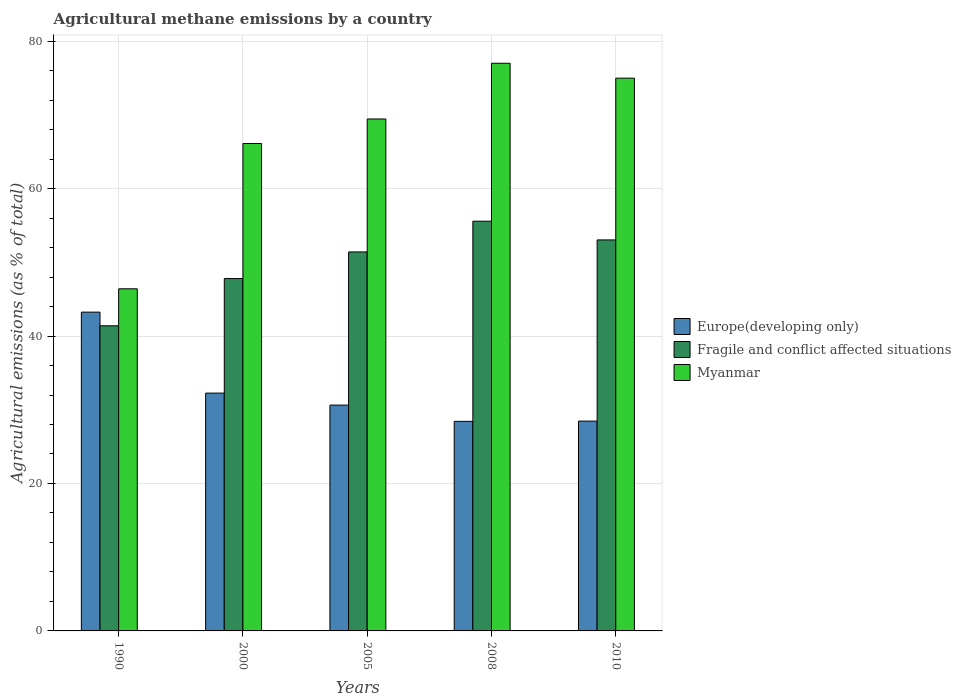How many groups of bars are there?
Keep it short and to the point. 5. Are the number of bars on each tick of the X-axis equal?
Your response must be concise. Yes. What is the amount of agricultural methane emitted in Fragile and conflict affected situations in 1990?
Your answer should be very brief. 41.39. Across all years, what is the maximum amount of agricultural methane emitted in Europe(developing only)?
Give a very brief answer. 43.24. Across all years, what is the minimum amount of agricultural methane emitted in Fragile and conflict affected situations?
Your answer should be compact. 41.39. In which year was the amount of agricultural methane emitted in Europe(developing only) minimum?
Provide a succinct answer. 2008. What is the total amount of agricultural methane emitted in Myanmar in the graph?
Offer a terse response. 333.95. What is the difference between the amount of agricultural methane emitted in Myanmar in 1990 and that in 2008?
Your response must be concise. -30.59. What is the difference between the amount of agricultural methane emitted in Europe(developing only) in 2000 and the amount of agricultural methane emitted in Fragile and conflict affected situations in 2005?
Offer a terse response. -19.15. What is the average amount of agricultural methane emitted in Fragile and conflict affected situations per year?
Offer a very short reply. 49.84. In the year 2008, what is the difference between the amount of agricultural methane emitted in Myanmar and amount of agricultural methane emitted in Europe(developing only)?
Provide a short and direct response. 48.57. In how many years, is the amount of agricultural methane emitted in Fragile and conflict affected situations greater than 52 %?
Offer a very short reply. 2. What is the ratio of the amount of agricultural methane emitted in Myanmar in 1990 to that in 2005?
Give a very brief answer. 0.67. Is the amount of agricultural methane emitted in Myanmar in 1990 less than that in 2008?
Provide a succinct answer. Yes. What is the difference between the highest and the second highest amount of agricultural methane emitted in Myanmar?
Your answer should be compact. 2.02. What is the difference between the highest and the lowest amount of agricultural methane emitted in Fragile and conflict affected situations?
Offer a very short reply. 14.19. Is the sum of the amount of agricultural methane emitted in Europe(developing only) in 1990 and 2010 greater than the maximum amount of agricultural methane emitted in Myanmar across all years?
Your answer should be very brief. No. What does the 1st bar from the left in 2005 represents?
Provide a succinct answer. Europe(developing only). What does the 3rd bar from the right in 2008 represents?
Offer a terse response. Europe(developing only). Is it the case that in every year, the sum of the amount of agricultural methane emitted in Europe(developing only) and amount of agricultural methane emitted in Myanmar is greater than the amount of agricultural methane emitted in Fragile and conflict affected situations?
Offer a terse response. Yes. How many bars are there?
Give a very brief answer. 15. Are all the bars in the graph horizontal?
Make the answer very short. No. How many years are there in the graph?
Make the answer very short. 5. Are the values on the major ticks of Y-axis written in scientific E-notation?
Offer a terse response. No. Does the graph contain grids?
Give a very brief answer. Yes. What is the title of the graph?
Provide a succinct answer. Agricultural methane emissions by a country. Does "Monaco" appear as one of the legend labels in the graph?
Your response must be concise. No. What is the label or title of the X-axis?
Offer a terse response. Years. What is the label or title of the Y-axis?
Make the answer very short. Agricultural emissions (as % of total). What is the Agricultural emissions (as % of total) of Europe(developing only) in 1990?
Your answer should be compact. 43.24. What is the Agricultural emissions (as % of total) of Fragile and conflict affected situations in 1990?
Give a very brief answer. 41.39. What is the Agricultural emissions (as % of total) of Myanmar in 1990?
Provide a short and direct response. 46.41. What is the Agricultural emissions (as % of total) of Europe(developing only) in 2000?
Offer a very short reply. 32.26. What is the Agricultural emissions (as % of total) of Fragile and conflict affected situations in 2000?
Provide a succinct answer. 47.8. What is the Agricultural emissions (as % of total) in Myanmar in 2000?
Keep it short and to the point. 66.12. What is the Agricultural emissions (as % of total) in Europe(developing only) in 2005?
Provide a succinct answer. 30.63. What is the Agricultural emissions (as % of total) of Fragile and conflict affected situations in 2005?
Provide a short and direct response. 51.41. What is the Agricultural emissions (as % of total) of Myanmar in 2005?
Ensure brevity in your answer.  69.44. What is the Agricultural emissions (as % of total) in Europe(developing only) in 2008?
Offer a terse response. 28.43. What is the Agricultural emissions (as % of total) in Fragile and conflict affected situations in 2008?
Offer a terse response. 55.58. What is the Agricultural emissions (as % of total) of Myanmar in 2008?
Give a very brief answer. 77. What is the Agricultural emissions (as % of total) of Europe(developing only) in 2010?
Make the answer very short. 28.46. What is the Agricultural emissions (as % of total) of Fragile and conflict affected situations in 2010?
Ensure brevity in your answer.  53.04. What is the Agricultural emissions (as % of total) in Myanmar in 2010?
Make the answer very short. 74.98. Across all years, what is the maximum Agricultural emissions (as % of total) in Europe(developing only)?
Your response must be concise. 43.24. Across all years, what is the maximum Agricultural emissions (as % of total) of Fragile and conflict affected situations?
Give a very brief answer. 55.58. Across all years, what is the maximum Agricultural emissions (as % of total) of Myanmar?
Offer a very short reply. 77. Across all years, what is the minimum Agricultural emissions (as % of total) in Europe(developing only)?
Your answer should be compact. 28.43. Across all years, what is the minimum Agricultural emissions (as % of total) of Fragile and conflict affected situations?
Provide a succinct answer. 41.39. Across all years, what is the minimum Agricultural emissions (as % of total) of Myanmar?
Keep it short and to the point. 46.41. What is the total Agricultural emissions (as % of total) in Europe(developing only) in the graph?
Your answer should be very brief. 163.02. What is the total Agricultural emissions (as % of total) of Fragile and conflict affected situations in the graph?
Offer a very short reply. 249.21. What is the total Agricultural emissions (as % of total) of Myanmar in the graph?
Keep it short and to the point. 333.95. What is the difference between the Agricultural emissions (as % of total) in Europe(developing only) in 1990 and that in 2000?
Offer a terse response. 10.98. What is the difference between the Agricultural emissions (as % of total) of Fragile and conflict affected situations in 1990 and that in 2000?
Make the answer very short. -6.41. What is the difference between the Agricultural emissions (as % of total) of Myanmar in 1990 and that in 2000?
Provide a succinct answer. -19.71. What is the difference between the Agricultural emissions (as % of total) in Europe(developing only) in 1990 and that in 2005?
Offer a terse response. 12.61. What is the difference between the Agricultural emissions (as % of total) in Fragile and conflict affected situations in 1990 and that in 2005?
Your response must be concise. -10.02. What is the difference between the Agricultural emissions (as % of total) in Myanmar in 1990 and that in 2005?
Make the answer very short. -23.03. What is the difference between the Agricultural emissions (as % of total) of Europe(developing only) in 1990 and that in 2008?
Offer a very short reply. 14.82. What is the difference between the Agricultural emissions (as % of total) of Fragile and conflict affected situations in 1990 and that in 2008?
Give a very brief answer. -14.19. What is the difference between the Agricultural emissions (as % of total) in Myanmar in 1990 and that in 2008?
Offer a terse response. -30.59. What is the difference between the Agricultural emissions (as % of total) in Europe(developing only) in 1990 and that in 2010?
Give a very brief answer. 14.78. What is the difference between the Agricultural emissions (as % of total) in Fragile and conflict affected situations in 1990 and that in 2010?
Keep it short and to the point. -11.65. What is the difference between the Agricultural emissions (as % of total) of Myanmar in 1990 and that in 2010?
Your answer should be compact. -28.57. What is the difference between the Agricultural emissions (as % of total) in Europe(developing only) in 2000 and that in 2005?
Your answer should be compact. 1.63. What is the difference between the Agricultural emissions (as % of total) in Fragile and conflict affected situations in 2000 and that in 2005?
Provide a short and direct response. -3.61. What is the difference between the Agricultural emissions (as % of total) in Myanmar in 2000 and that in 2005?
Provide a succinct answer. -3.32. What is the difference between the Agricultural emissions (as % of total) in Europe(developing only) in 2000 and that in 2008?
Make the answer very short. 3.83. What is the difference between the Agricultural emissions (as % of total) in Fragile and conflict affected situations in 2000 and that in 2008?
Offer a terse response. -7.78. What is the difference between the Agricultural emissions (as % of total) of Myanmar in 2000 and that in 2008?
Your response must be concise. -10.88. What is the difference between the Agricultural emissions (as % of total) of Europe(developing only) in 2000 and that in 2010?
Provide a succinct answer. 3.8. What is the difference between the Agricultural emissions (as % of total) of Fragile and conflict affected situations in 2000 and that in 2010?
Give a very brief answer. -5.24. What is the difference between the Agricultural emissions (as % of total) in Myanmar in 2000 and that in 2010?
Provide a succinct answer. -8.86. What is the difference between the Agricultural emissions (as % of total) in Europe(developing only) in 2005 and that in 2008?
Your response must be concise. 2.2. What is the difference between the Agricultural emissions (as % of total) in Fragile and conflict affected situations in 2005 and that in 2008?
Offer a very short reply. -4.17. What is the difference between the Agricultural emissions (as % of total) of Myanmar in 2005 and that in 2008?
Keep it short and to the point. -7.56. What is the difference between the Agricultural emissions (as % of total) of Europe(developing only) in 2005 and that in 2010?
Your response must be concise. 2.17. What is the difference between the Agricultural emissions (as % of total) of Fragile and conflict affected situations in 2005 and that in 2010?
Offer a terse response. -1.63. What is the difference between the Agricultural emissions (as % of total) in Myanmar in 2005 and that in 2010?
Give a very brief answer. -5.54. What is the difference between the Agricultural emissions (as % of total) of Europe(developing only) in 2008 and that in 2010?
Offer a terse response. -0.03. What is the difference between the Agricultural emissions (as % of total) in Fragile and conflict affected situations in 2008 and that in 2010?
Provide a succinct answer. 2.54. What is the difference between the Agricultural emissions (as % of total) in Myanmar in 2008 and that in 2010?
Keep it short and to the point. 2.02. What is the difference between the Agricultural emissions (as % of total) in Europe(developing only) in 1990 and the Agricultural emissions (as % of total) in Fragile and conflict affected situations in 2000?
Give a very brief answer. -4.55. What is the difference between the Agricultural emissions (as % of total) of Europe(developing only) in 1990 and the Agricultural emissions (as % of total) of Myanmar in 2000?
Give a very brief answer. -22.88. What is the difference between the Agricultural emissions (as % of total) in Fragile and conflict affected situations in 1990 and the Agricultural emissions (as % of total) in Myanmar in 2000?
Your answer should be very brief. -24.73. What is the difference between the Agricultural emissions (as % of total) of Europe(developing only) in 1990 and the Agricultural emissions (as % of total) of Fragile and conflict affected situations in 2005?
Your answer should be compact. -8.17. What is the difference between the Agricultural emissions (as % of total) of Europe(developing only) in 1990 and the Agricultural emissions (as % of total) of Myanmar in 2005?
Ensure brevity in your answer.  -26.2. What is the difference between the Agricultural emissions (as % of total) in Fragile and conflict affected situations in 1990 and the Agricultural emissions (as % of total) in Myanmar in 2005?
Your answer should be very brief. -28.05. What is the difference between the Agricultural emissions (as % of total) in Europe(developing only) in 1990 and the Agricultural emissions (as % of total) in Fragile and conflict affected situations in 2008?
Your answer should be very brief. -12.34. What is the difference between the Agricultural emissions (as % of total) of Europe(developing only) in 1990 and the Agricultural emissions (as % of total) of Myanmar in 2008?
Ensure brevity in your answer.  -33.76. What is the difference between the Agricultural emissions (as % of total) of Fragile and conflict affected situations in 1990 and the Agricultural emissions (as % of total) of Myanmar in 2008?
Your answer should be compact. -35.61. What is the difference between the Agricultural emissions (as % of total) of Europe(developing only) in 1990 and the Agricultural emissions (as % of total) of Fragile and conflict affected situations in 2010?
Your response must be concise. -9.8. What is the difference between the Agricultural emissions (as % of total) in Europe(developing only) in 1990 and the Agricultural emissions (as % of total) in Myanmar in 2010?
Offer a very short reply. -31.74. What is the difference between the Agricultural emissions (as % of total) of Fragile and conflict affected situations in 1990 and the Agricultural emissions (as % of total) of Myanmar in 2010?
Your response must be concise. -33.59. What is the difference between the Agricultural emissions (as % of total) in Europe(developing only) in 2000 and the Agricultural emissions (as % of total) in Fragile and conflict affected situations in 2005?
Your response must be concise. -19.15. What is the difference between the Agricultural emissions (as % of total) in Europe(developing only) in 2000 and the Agricultural emissions (as % of total) in Myanmar in 2005?
Ensure brevity in your answer.  -37.18. What is the difference between the Agricultural emissions (as % of total) of Fragile and conflict affected situations in 2000 and the Agricultural emissions (as % of total) of Myanmar in 2005?
Provide a succinct answer. -21.64. What is the difference between the Agricultural emissions (as % of total) in Europe(developing only) in 2000 and the Agricultural emissions (as % of total) in Fragile and conflict affected situations in 2008?
Your answer should be very brief. -23.32. What is the difference between the Agricultural emissions (as % of total) of Europe(developing only) in 2000 and the Agricultural emissions (as % of total) of Myanmar in 2008?
Offer a terse response. -44.74. What is the difference between the Agricultural emissions (as % of total) of Fragile and conflict affected situations in 2000 and the Agricultural emissions (as % of total) of Myanmar in 2008?
Your response must be concise. -29.2. What is the difference between the Agricultural emissions (as % of total) in Europe(developing only) in 2000 and the Agricultural emissions (as % of total) in Fragile and conflict affected situations in 2010?
Ensure brevity in your answer.  -20.78. What is the difference between the Agricultural emissions (as % of total) of Europe(developing only) in 2000 and the Agricultural emissions (as % of total) of Myanmar in 2010?
Your answer should be very brief. -42.72. What is the difference between the Agricultural emissions (as % of total) in Fragile and conflict affected situations in 2000 and the Agricultural emissions (as % of total) in Myanmar in 2010?
Give a very brief answer. -27.19. What is the difference between the Agricultural emissions (as % of total) of Europe(developing only) in 2005 and the Agricultural emissions (as % of total) of Fragile and conflict affected situations in 2008?
Your answer should be very brief. -24.95. What is the difference between the Agricultural emissions (as % of total) in Europe(developing only) in 2005 and the Agricultural emissions (as % of total) in Myanmar in 2008?
Ensure brevity in your answer.  -46.37. What is the difference between the Agricultural emissions (as % of total) in Fragile and conflict affected situations in 2005 and the Agricultural emissions (as % of total) in Myanmar in 2008?
Your answer should be compact. -25.59. What is the difference between the Agricultural emissions (as % of total) of Europe(developing only) in 2005 and the Agricultural emissions (as % of total) of Fragile and conflict affected situations in 2010?
Offer a terse response. -22.41. What is the difference between the Agricultural emissions (as % of total) in Europe(developing only) in 2005 and the Agricultural emissions (as % of total) in Myanmar in 2010?
Keep it short and to the point. -44.35. What is the difference between the Agricultural emissions (as % of total) in Fragile and conflict affected situations in 2005 and the Agricultural emissions (as % of total) in Myanmar in 2010?
Your answer should be compact. -23.57. What is the difference between the Agricultural emissions (as % of total) in Europe(developing only) in 2008 and the Agricultural emissions (as % of total) in Fragile and conflict affected situations in 2010?
Your response must be concise. -24.61. What is the difference between the Agricultural emissions (as % of total) in Europe(developing only) in 2008 and the Agricultural emissions (as % of total) in Myanmar in 2010?
Ensure brevity in your answer.  -46.55. What is the difference between the Agricultural emissions (as % of total) in Fragile and conflict affected situations in 2008 and the Agricultural emissions (as % of total) in Myanmar in 2010?
Your response must be concise. -19.4. What is the average Agricultural emissions (as % of total) in Europe(developing only) per year?
Ensure brevity in your answer.  32.6. What is the average Agricultural emissions (as % of total) of Fragile and conflict affected situations per year?
Your answer should be compact. 49.84. What is the average Agricultural emissions (as % of total) of Myanmar per year?
Make the answer very short. 66.79. In the year 1990, what is the difference between the Agricultural emissions (as % of total) of Europe(developing only) and Agricultural emissions (as % of total) of Fragile and conflict affected situations?
Your answer should be very brief. 1.85. In the year 1990, what is the difference between the Agricultural emissions (as % of total) of Europe(developing only) and Agricultural emissions (as % of total) of Myanmar?
Ensure brevity in your answer.  -3.16. In the year 1990, what is the difference between the Agricultural emissions (as % of total) of Fragile and conflict affected situations and Agricultural emissions (as % of total) of Myanmar?
Make the answer very short. -5.02. In the year 2000, what is the difference between the Agricultural emissions (as % of total) of Europe(developing only) and Agricultural emissions (as % of total) of Fragile and conflict affected situations?
Your answer should be compact. -15.54. In the year 2000, what is the difference between the Agricultural emissions (as % of total) of Europe(developing only) and Agricultural emissions (as % of total) of Myanmar?
Provide a short and direct response. -33.86. In the year 2000, what is the difference between the Agricultural emissions (as % of total) of Fragile and conflict affected situations and Agricultural emissions (as % of total) of Myanmar?
Give a very brief answer. -18.32. In the year 2005, what is the difference between the Agricultural emissions (as % of total) in Europe(developing only) and Agricultural emissions (as % of total) in Fragile and conflict affected situations?
Make the answer very short. -20.78. In the year 2005, what is the difference between the Agricultural emissions (as % of total) of Europe(developing only) and Agricultural emissions (as % of total) of Myanmar?
Make the answer very short. -38.81. In the year 2005, what is the difference between the Agricultural emissions (as % of total) in Fragile and conflict affected situations and Agricultural emissions (as % of total) in Myanmar?
Your response must be concise. -18.03. In the year 2008, what is the difference between the Agricultural emissions (as % of total) of Europe(developing only) and Agricultural emissions (as % of total) of Fragile and conflict affected situations?
Offer a terse response. -27.15. In the year 2008, what is the difference between the Agricultural emissions (as % of total) in Europe(developing only) and Agricultural emissions (as % of total) in Myanmar?
Keep it short and to the point. -48.57. In the year 2008, what is the difference between the Agricultural emissions (as % of total) in Fragile and conflict affected situations and Agricultural emissions (as % of total) in Myanmar?
Offer a very short reply. -21.42. In the year 2010, what is the difference between the Agricultural emissions (as % of total) of Europe(developing only) and Agricultural emissions (as % of total) of Fragile and conflict affected situations?
Your answer should be compact. -24.58. In the year 2010, what is the difference between the Agricultural emissions (as % of total) of Europe(developing only) and Agricultural emissions (as % of total) of Myanmar?
Keep it short and to the point. -46.52. In the year 2010, what is the difference between the Agricultural emissions (as % of total) of Fragile and conflict affected situations and Agricultural emissions (as % of total) of Myanmar?
Offer a very short reply. -21.94. What is the ratio of the Agricultural emissions (as % of total) in Europe(developing only) in 1990 to that in 2000?
Your answer should be very brief. 1.34. What is the ratio of the Agricultural emissions (as % of total) in Fragile and conflict affected situations in 1990 to that in 2000?
Give a very brief answer. 0.87. What is the ratio of the Agricultural emissions (as % of total) in Myanmar in 1990 to that in 2000?
Provide a short and direct response. 0.7. What is the ratio of the Agricultural emissions (as % of total) in Europe(developing only) in 1990 to that in 2005?
Offer a very short reply. 1.41. What is the ratio of the Agricultural emissions (as % of total) in Fragile and conflict affected situations in 1990 to that in 2005?
Your answer should be compact. 0.81. What is the ratio of the Agricultural emissions (as % of total) in Myanmar in 1990 to that in 2005?
Your answer should be compact. 0.67. What is the ratio of the Agricultural emissions (as % of total) in Europe(developing only) in 1990 to that in 2008?
Offer a very short reply. 1.52. What is the ratio of the Agricultural emissions (as % of total) of Fragile and conflict affected situations in 1990 to that in 2008?
Give a very brief answer. 0.74. What is the ratio of the Agricultural emissions (as % of total) of Myanmar in 1990 to that in 2008?
Ensure brevity in your answer.  0.6. What is the ratio of the Agricultural emissions (as % of total) in Europe(developing only) in 1990 to that in 2010?
Keep it short and to the point. 1.52. What is the ratio of the Agricultural emissions (as % of total) of Fragile and conflict affected situations in 1990 to that in 2010?
Your answer should be very brief. 0.78. What is the ratio of the Agricultural emissions (as % of total) in Myanmar in 1990 to that in 2010?
Your response must be concise. 0.62. What is the ratio of the Agricultural emissions (as % of total) in Europe(developing only) in 2000 to that in 2005?
Give a very brief answer. 1.05. What is the ratio of the Agricultural emissions (as % of total) in Fragile and conflict affected situations in 2000 to that in 2005?
Provide a succinct answer. 0.93. What is the ratio of the Agricultural emissions (as % of total) in Myanmar in 2000 to that in 2005?
Offer a terse response. 0.95. What is the ratio of the Agricultural emissions (as % of total) of Europe(developing only) in 2000 to that in 2008?
Your answer should be compact. 1.13. What is the ratio of the Agricultural emissions (as % of total) of Fragile and conflict affected situations in 2000 to that in 2008?
Provide a short and direct response. 0.86. What is the ratio of the Agricultural emissions (as % of total) in Myanmar in 2000 to that in 2008?
Give a very brief answer. 0.86. What is the ratio of the Agricultural emissions (as % of total) of Europe(developing only) in 2000 to that in 2010?
Ensure brevity in your answer.  1.13. What is the ratio of the Agricultural emissions (as % of total) of Fragile and conflict affected situations in 2000 to that in 2010?
Provide a short and direct response. 0.9. What is the ratio of the Agricultural emissions (as % of total) of Myanmar in 2000 to that in 2010?
Keep it short and to the point. 0.88. What is the ratio of the Agricultural emissions (as % of total) of Europe(developing only) in 2005 to that in 2008?
Ensure brevity in your answer.  1.08. What is the ratio of the Agricultural emissions (as % of total) of Fragile and conflict affected situations in 2005 to that in 2008?
Your answer should be very brief. 0.93. What is the ratio of the Agricultural emissions (as % of total) of Myanmar in 2005 to that in 2008?
Offer a very short reply. 0.9. What is the ratio of the Agricultural emissions (as % of total) in Europe(developing only) in 2005 to that in 2010?
Keep it short and to the point. 1.08. What is the ratio of the Agricultural emissions (as % of total) of Fragile and conflict affected situations in 2005 to that in 2010?
Provide a short and direct response. 0.97. What is the ratio of the Agricultural emissions (as % of total) in Myanmar in 2005 to that in 2010?
Offer a very short reply. 0.93. What is the ratio of the Agricultural emissions (as % of total) in Fragile and conflict affected situations in 2008 to that in 2010?
Offer a terse response. 1.05. What is the ratio of the Agricultural emissions (as % of total) of Myanmar in 2008 to that in 2010?
Offer a terse response. 1.03. What is the difference between the highest and the second highest Agricultural emissions (as % of total) of Europe(developing only)?
Offer a very short reply. 10.98. What is the difference between the highest and the second highest Agricultural emissions (as % of total) in Fragile and conflict affected situations?
Give a very brief answer. 2.54. What is the difference between the highest and the second highest Agricultural emissions (as % of total) of Myanmar?
Your answer should be very brief. 2.02. What is the difference between the highest and the lowest Agricultural emissions (as % of total) in Europe(developing only)?
Your answer should be very brief. 14.82. What is the difference between the highest and the lowest Agricultural emissions (as % of total) in Fragile and conflict affected situations?
Make the answer very short. 14.19. What is the difference between the highest and the lowest Agricultural emissions (as % of total) in Myanmar?
Give a very brief answer. 30.59. 